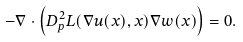<formula> <loc_0><loc_0><loc_500><loc_500>- \nabla \cdot \left ( D ^ { 2 } _ { p } L ( \nabla u ( x ) , x ) \nabla w ( x ) \right ) = 0 .</formula> 